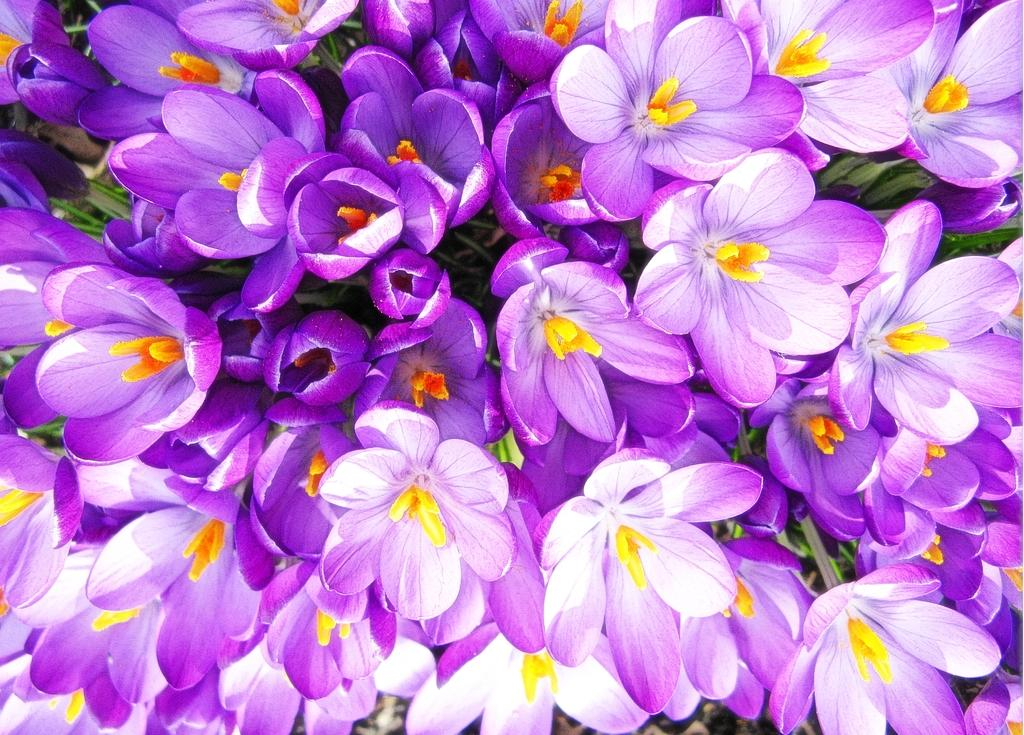What type of plants are in the image? There is a group of flowers in the image. What color are the flowers? The flowers are violet in color. What can be seen in the center of the flowers? There are yellow petals in the middle of the flowers. What other plants are present in the image? There are plant saplings in the middle of the flowers. What type of punishment is being given to the flowers in the image? There is no punishment being given to the flowers in the image; they are simply plants. Can you describe how the flowers are jumping in the image? Flowers do not have the ability to jump, so this action cannot be observed in the image. 